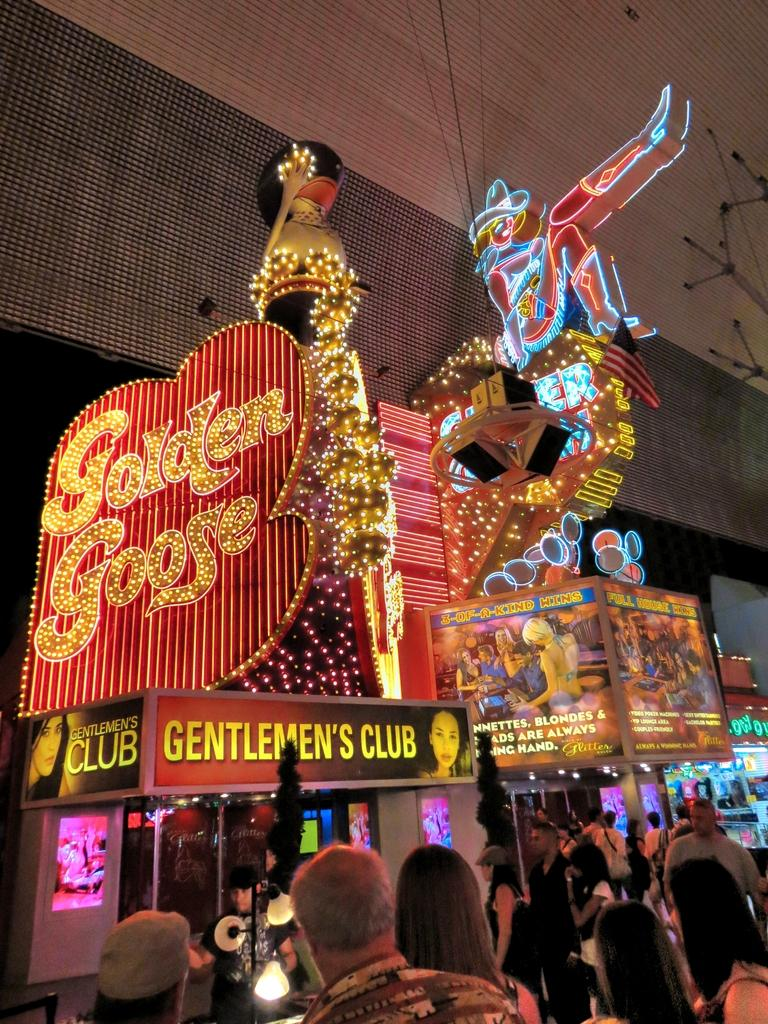What can be seen in the image in terms of human presence? There are people standing in the image. What objects are present in the image that are not people? There are boards and lights in the image. Is there any text or symbols visible in the image? Yes, there is writing at a few places in the image. How much sugar is present in the image? There is no sugar present in the image. What type of jelly can be seen on the boards in the image? There is no jelly present in the image; it only contains people, boards, lights, and writing. 